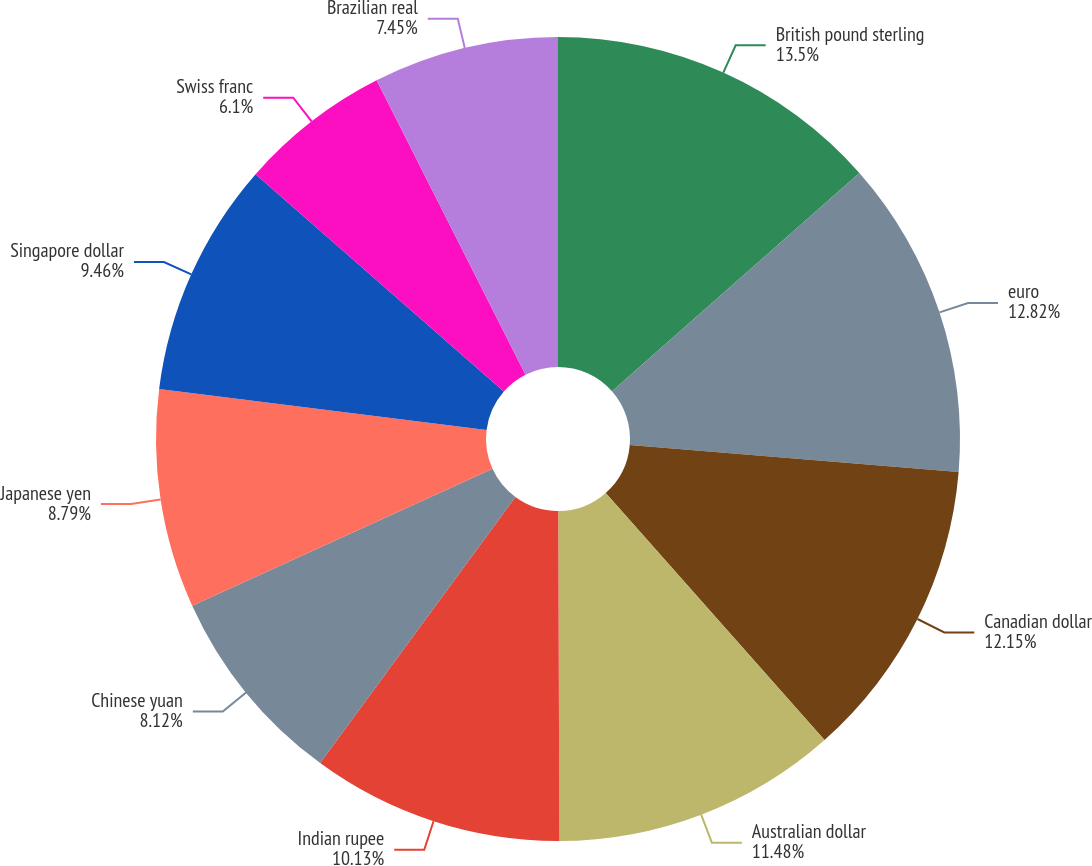Convert chart to OTSL. <chart><loc_0><loc_0><loc_500><loc_500><pie_chart><fcel>British pound sterling<fcel>euro<fcel>Canadian dollar<fcel>Australian dollar<fcel>Indian rupee<fcel>Chinese yuan<fcel>Japanese yen<fcel>Singapore dollar<fcel>Swiss franc<fcel>Brazilian real<nl><fcel>13.49%<fcel>12.82%<fcel>12.15%<fcel>11.48%<fcel>10.13%<fcel>8.12%<fcel>8.79%<fcel>9.46%<fcel>6.1%<fcel>7.45%<nl></chart> 